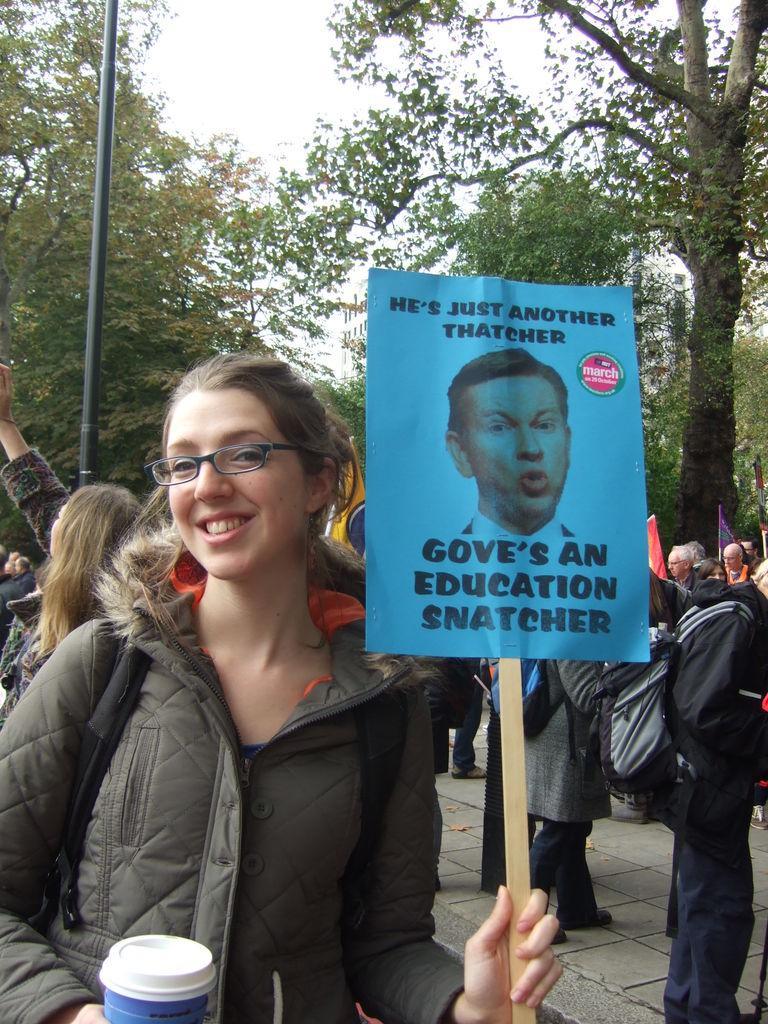How would you summarize this image in a sentence or two? In the given image i can see a lady holding a pamphlet and behind her i can see a people,rod and trees. 